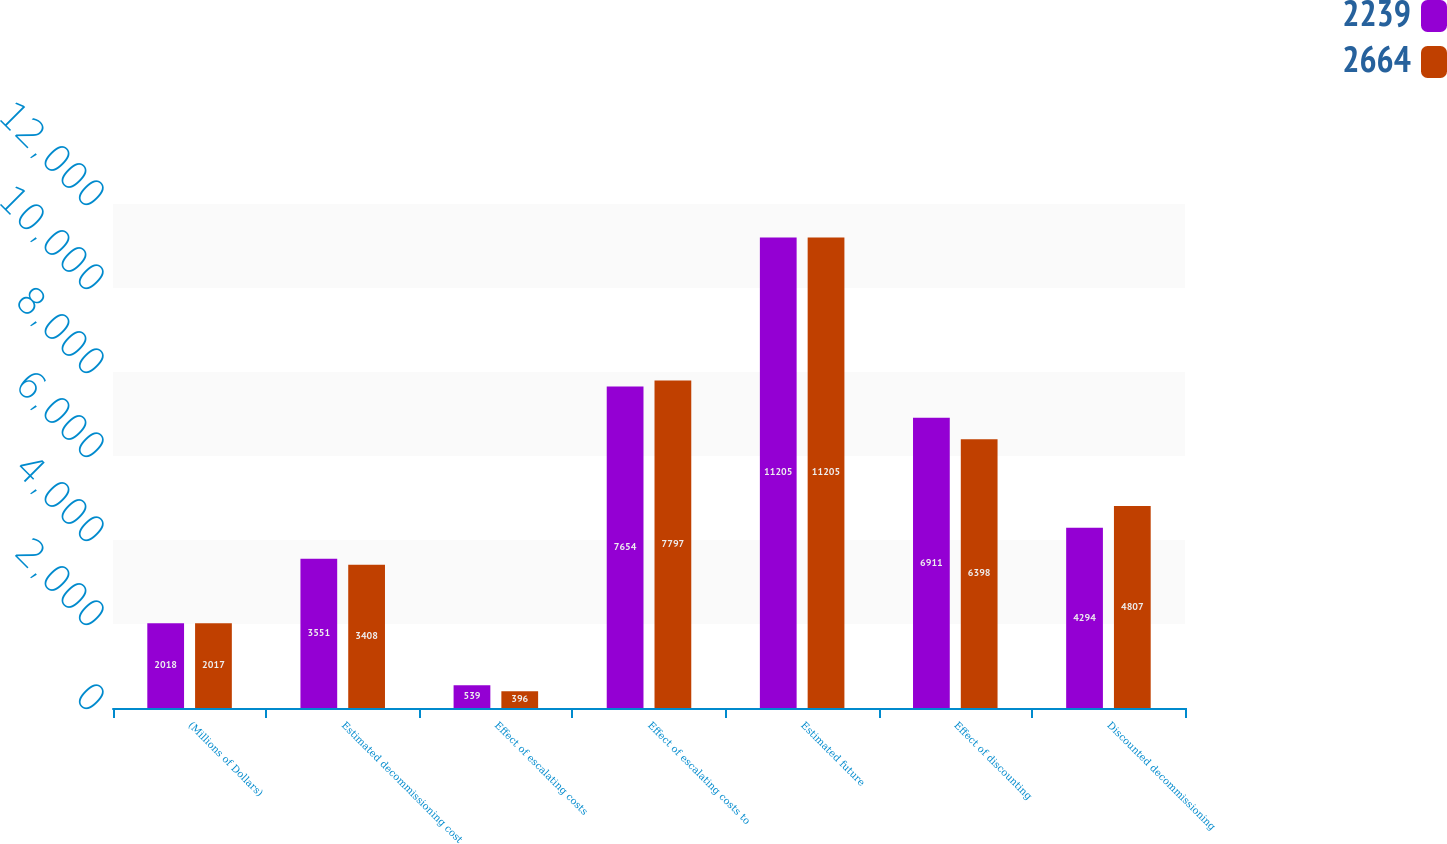Convert chart to OTSL. <chart><loc_0><loc_0><loc_500><loc_500><stacked_bar_chart><ecel><fcel>(Millions of Dollars)<fcel>Estimated decommissioning cost<fcel>Effect of escalating costs<fcel>Effect of escalating costs to<fcel>Estimated future<fcel>Effect of discounting<fcel>Discounted decommissioning<nl><fcel>2239<fcel>2018<fcel>3551<fcel>539<fcel>7654<fcel>11205<fcel>6911<fcel>4294<nl><fcel>2664<fcel>2017<fcel>3408<fcel>396<fcel>7797<fcel>11205<fcel>6398<fcel>4807<nl></chart> 